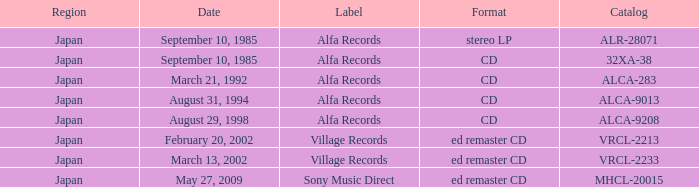Which Catalog was formated as a CD under the label Alfa Records? 32XA-38, ALCA-283, ALCA-9013, ALCA-9208. Give me the full table as a dictionary. {'header': ['Region', 'Date', 'Label', 'Format', 'Catalog'], 'rows': [['Japan', 'September 10, 1985', 'Alfa Records', 'stereo LP', 'ALR-28071'], ['Japan', 'September 10, 1985', 'Alfa Records', 'CD', '32XA-38'], ['Japan', 'March 21, 1992', 'Alfa Records', 'CD', 'ALCA-283'], ['Japan', 'August 31, 1994', 'Alfa Records', 'CD', 'ALCA-9013'], ['Japan', 'August 29, 1998', 'Alfa Records', 'CD', 'ALCA-9208'], ['Japan', 'February 20, 2002', 'Village Records', 'ed remaster CD', 'VRCL-2213'], ['Japan', 'March 13, 2002', 'Village Records', 'ed remaster CD', 'VRCL-2233'], ['Japan', 'May 27, 2009', 'Sony Music Direct', 'ed remaster CD', 'MHCL-20015']]} 